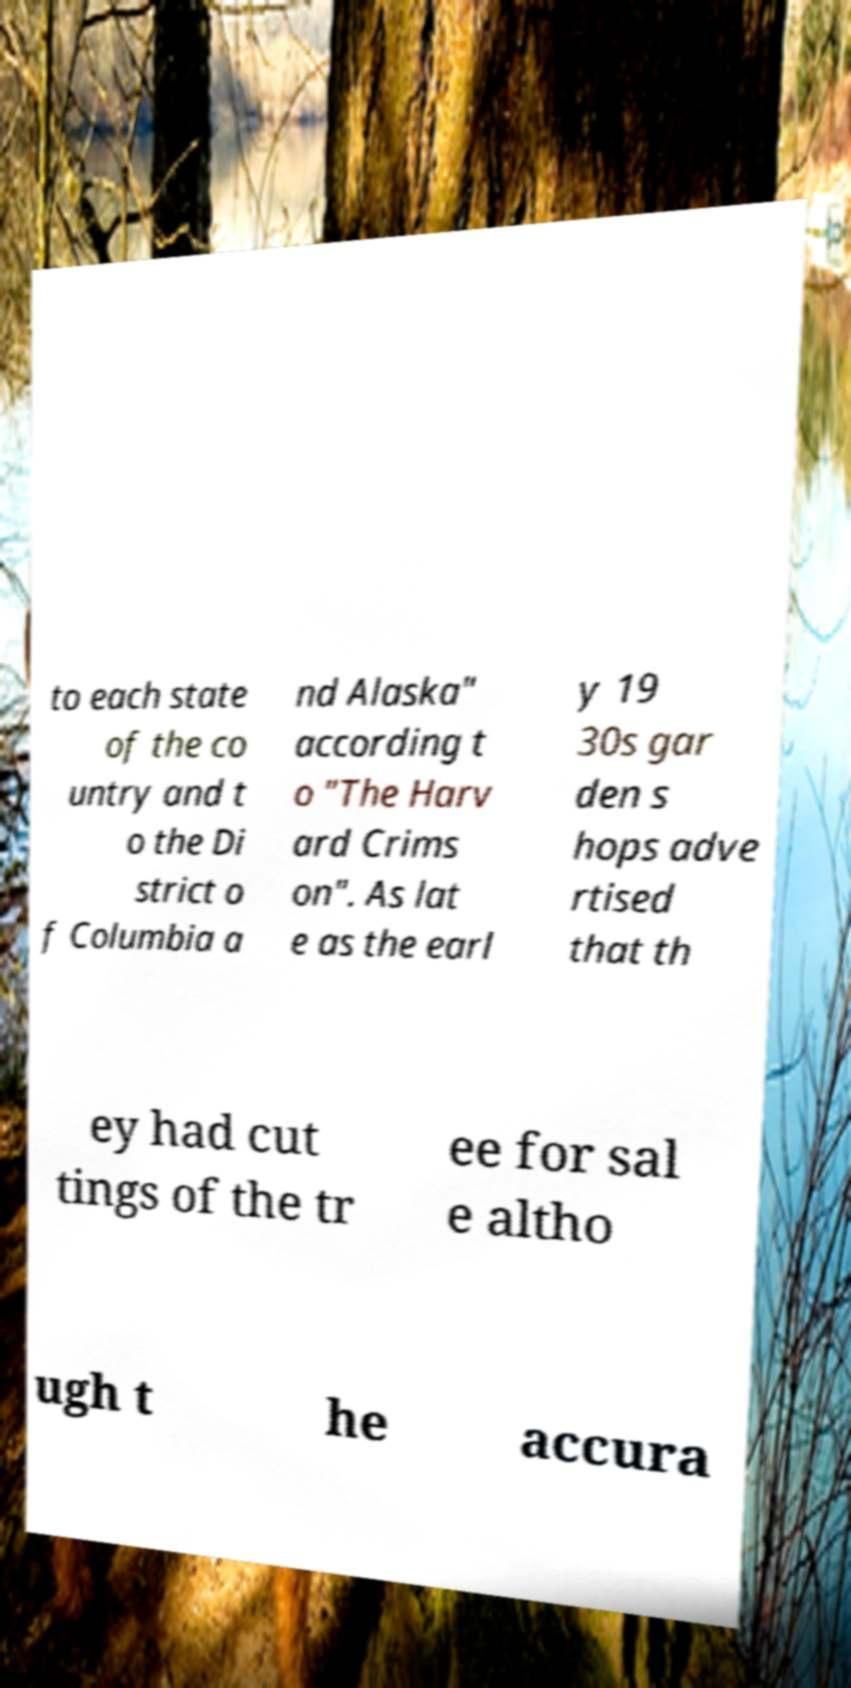Can you read and provide the text displayed in the image?This photo seems to have some interesting text. Can you extract and type it out for me? to each state of the co untry and t o the Di strict o f Columbia a nd Alaska" according t o "The Harv ard Crims on". As lat e as the earl y 19 30s gar den s hops adve rtised that th ey had cut tings of the tr ee for sal e altho ugh t he accura 